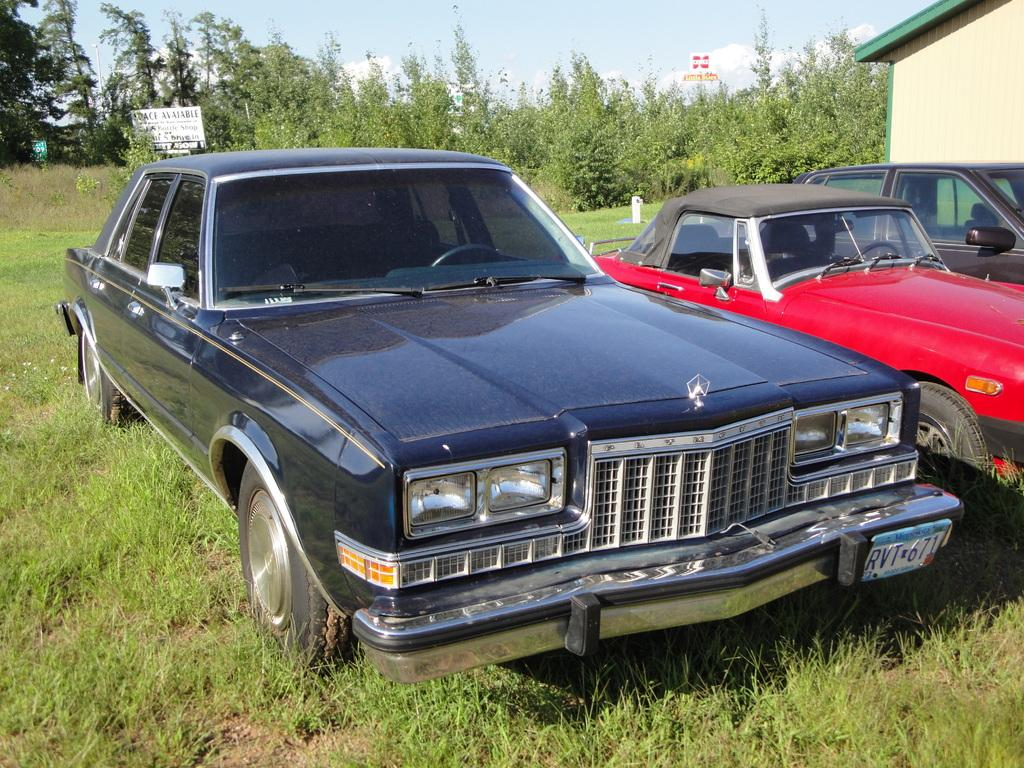What types of objects are on the ground in the image? There are vehicles on the ground in the image. What other elements can be seen in the image besides the vehicles? There are plants, boards, trees, and a building in the image. What is visible in the background of the image? The sky with clouds is visible in the background of the image. What type of beef can be seen hanging from the trees in the image? There is no beef present in the image; it features vehicles, plants, boards, trees, a building, and a sky with clouds. How is the string used in the image? There is no string present in the image. 